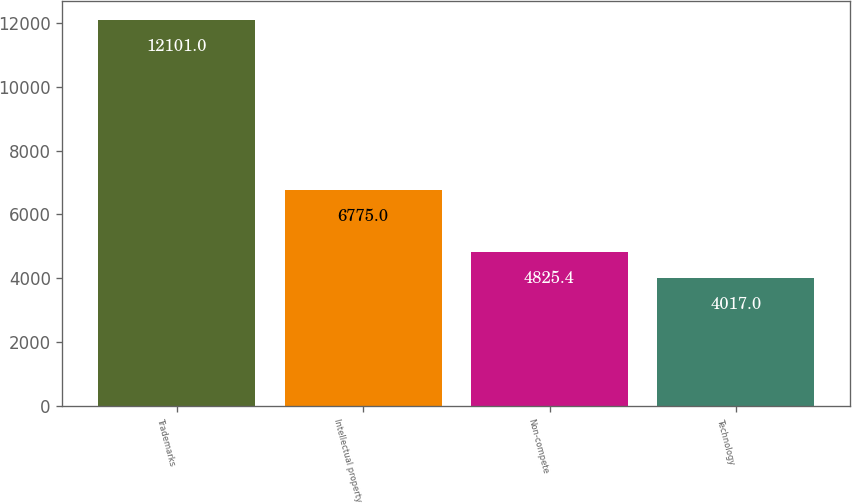Convert chart. <chart><loc_0><loc_0><loc_500><loc_500><bar_chart><fcel>Trademarks<fcel>Intellectual property<fcel>Non-compete<fcel>Technology<nl><fcel>12101<fcel>6775<fcel>4825.4<fcel>4017<nl></chart> 